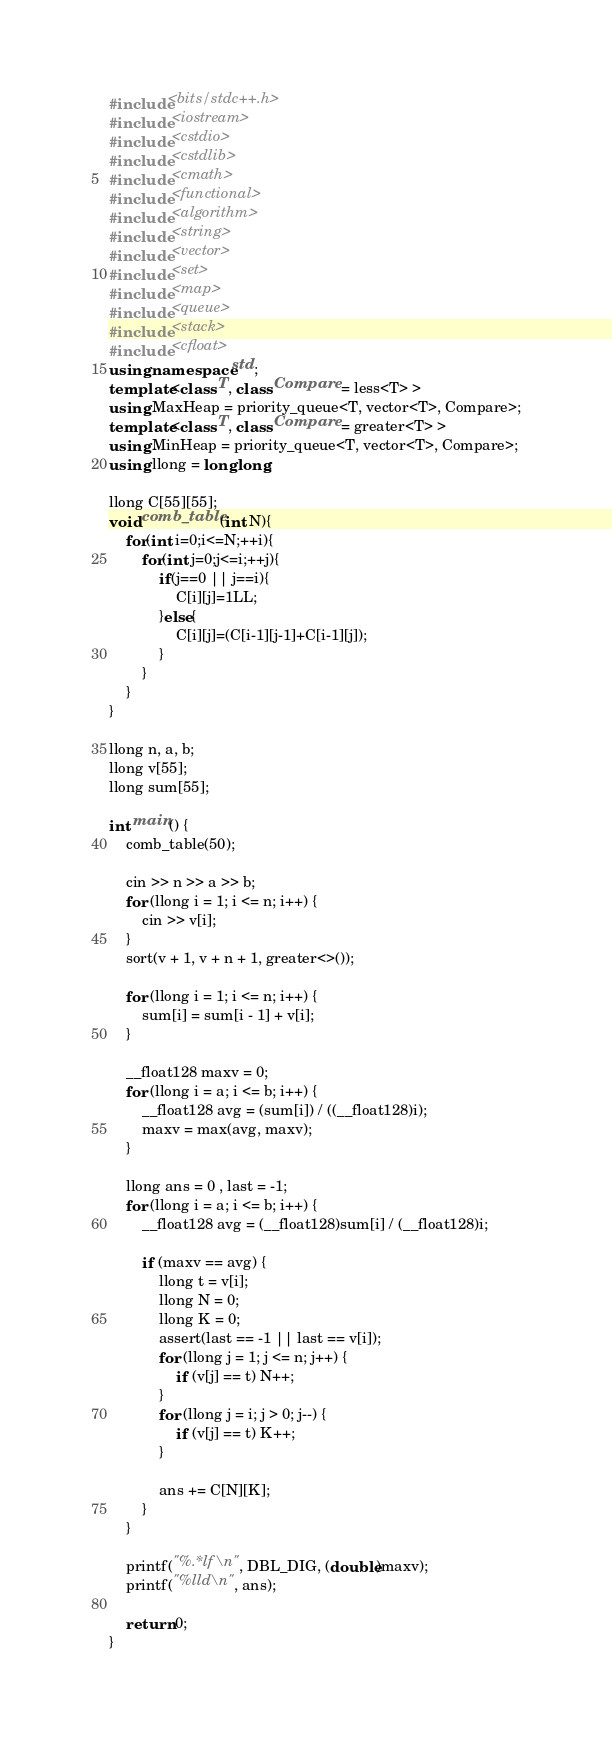Convert code to text. <code><loc_0><loc_0><loc_500><loc_500><_C++_>#include<bits/stdc++.h>
#include <iostream>
#include <cstdio>
#include <cstdlib>
#include <cmath>
#include <functional>
#include <algorithm>
#include <string>
#include <vector>
#include <set>
#include <map>
#include <queue>
#include <stack>
#include <cfloat>
using namespace std;
template<class T, class Compare = less<T> >
using MaxHeap = priority_queue<T, vector<T>, Compare>;
template<class T, class Compare = greater<T> >
using MinHeap = priority_queue<T, vector<T>, Compare>;
using llong = long long;

llong C[55][55];
void comb_table(int N){
    for(int i=0;i<=N;++i){
        for(int j=0;j<=i;++j){
            if(j==0 || j==i){
                C[i][j]=1LL;
            }else{
                C[i][j]=(C[i-1][j-1]+C[i-1][j]);
            }
        }
    }
}

llong n, a, b;
llong v[55];
llong sum[55];

int main() {
    comb_table(50);
    
    cin >> n >> a >> b;
    for (llong i = 1; i <= n; i++) {
        cin >> v[i];
    }
    sort(v + 1, v + n + 1, greater<>());

    for (llong i = 1; i <= n; i++) {
        sum[i] = sum[i - 1] + v[i];
    }

    __float128 maxv = 0;
    for (llong i = a; i <= b; i++) {
        __float128 avg = (sum[i]) / ((__float128)i);
        maxv = max(avg, maxv);
    }
    
    llong ans = 0 , last = -1;
    for (llong i = a; i <= b; i++) {
        __float128 avg = (__float128)sum[i] / (__float128)i;

        if (maxv == avg) {
            llong t = v[i];
            llong N = 0;
            llong K = 0;
            assert(last == -1 || last == v[i]);
            for (llong j = 1; j <= n; j++) {
                if (v[j] == t) N++;
            }
            for (llong j = i; j > 0; j--) {
                if (v[j] == t) K++;
            }

            ans += C[N][K];
        }
    }

    printf("%.*lf\n", DBL_DIG, (double)maxv);
    printf("%lld\n", ans);

    return 0;
}
</code> 